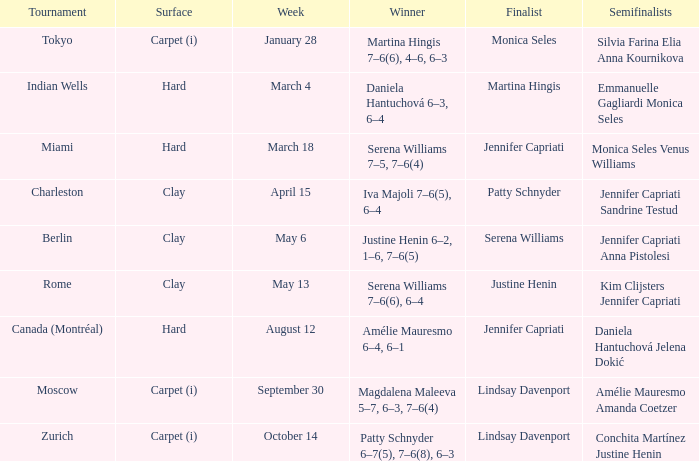What week was the finalist Martina Hingis? March 4. 